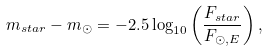Convert formula to latex. <formula><loc_0><loc_0><loc_500><loc_500>m _ { s t a r } - m _ { \odot } = - 2 . 5 \log _ { 1 0 } \left ( \frac { F _ { s t a r } } { F _ { \odot , E } } \right ) ,</formula> 